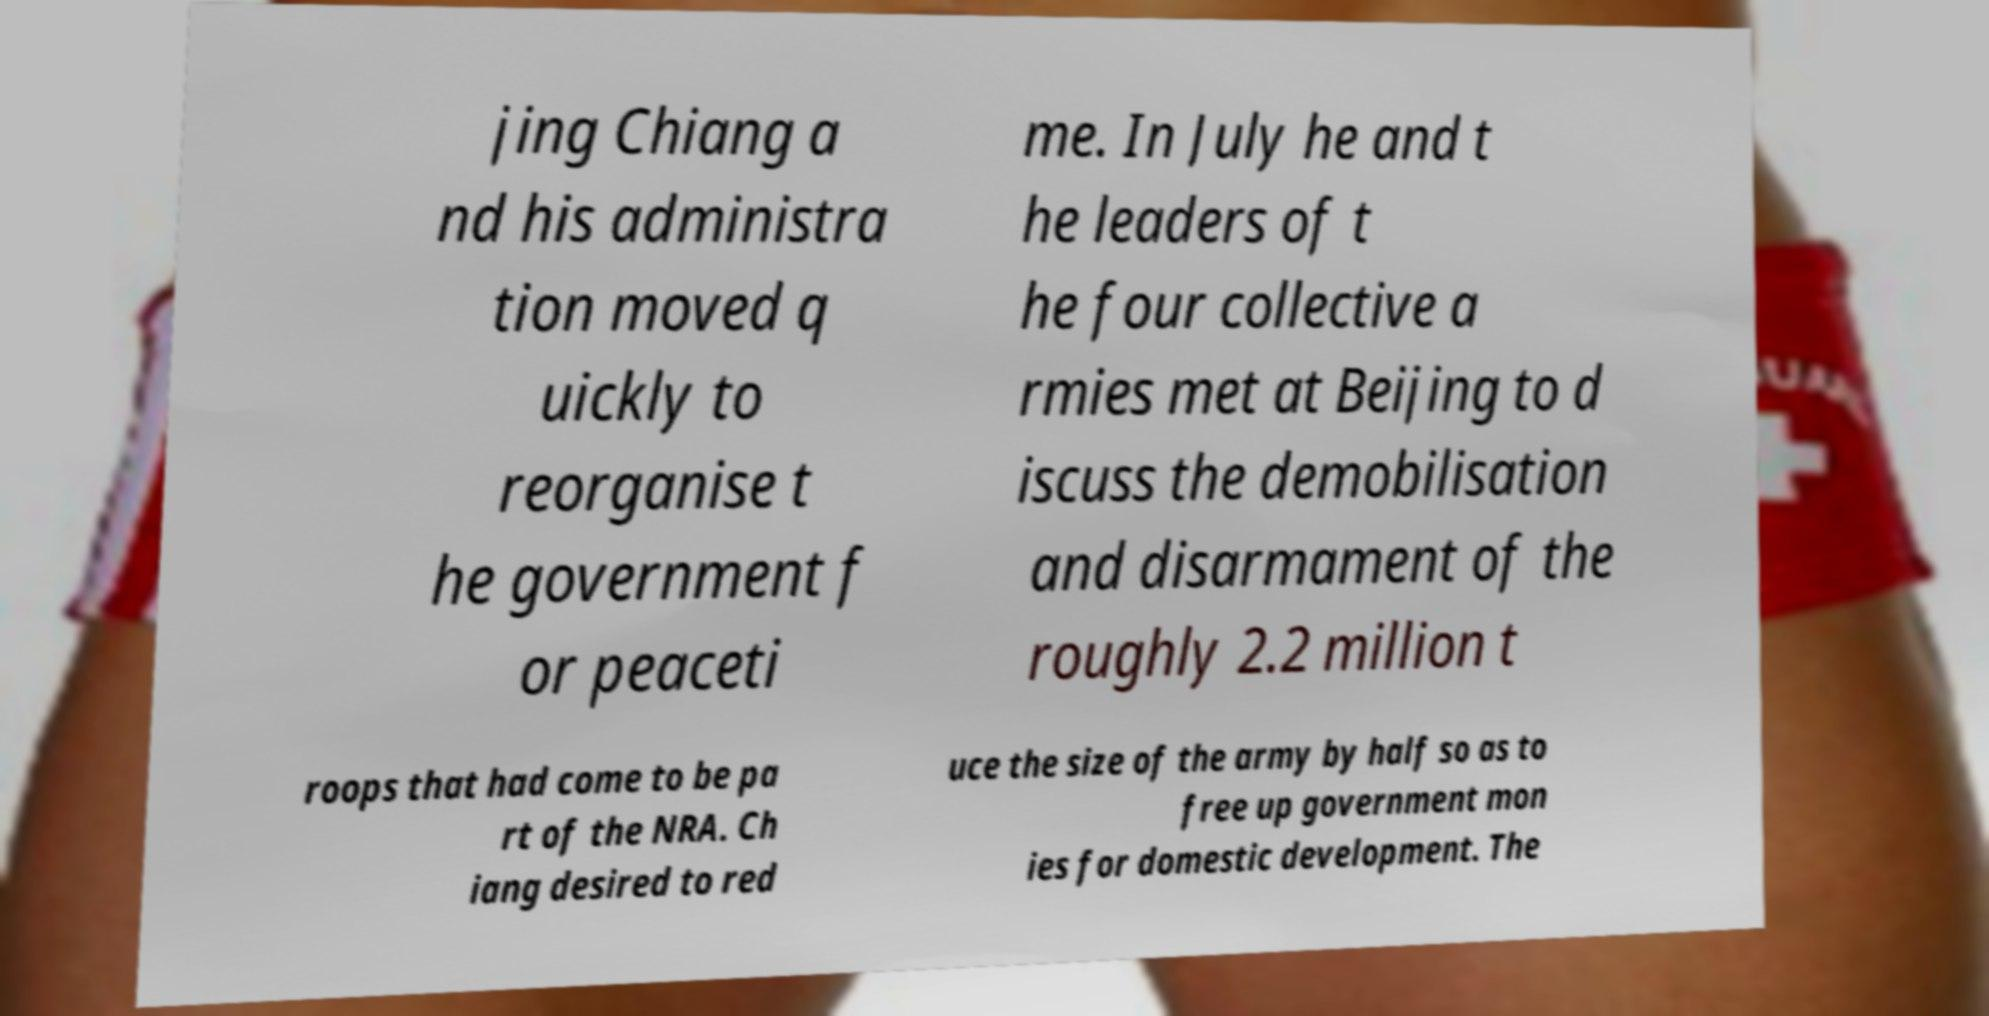Could you extract and type out the text from this image? jing Chiang a nd his administra tion moved q uickly to reorganise t he government f or peaceti me. In July he and t he leaders of t he four collective a rmies met at Beijing to d iscuss the demobilisation and disarmament of the roughly 2.2 million t roops that had come to be pa rt of the NRA. Ch iang desired to red uce the size of the army by half so as to free up government mon ies for domestic development. The 